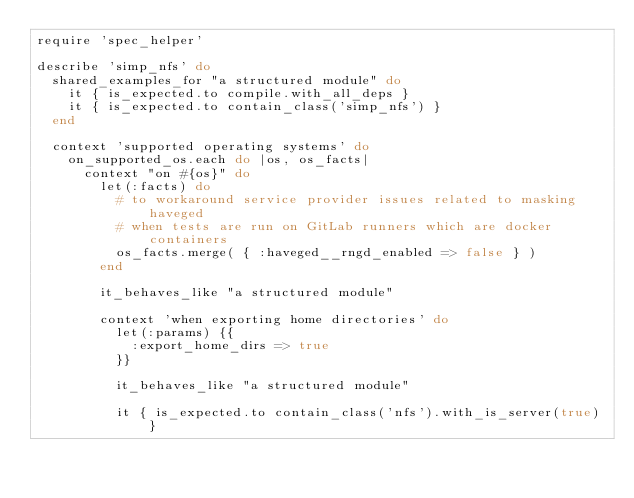Convert code to text. <code><loc_0><loc_0><loc_500><loc_500><_Ruby_>require 'spec_helper'

describe 'simp_nfs' do
  shared_examples_for "a structured module" do
    it { is_expected.to compile.with_all_deps }
    it { is_expected.to contain_class('simp_nfs') }
  end

  context 'supported operating systems' do
    on_supported_os.each do |os, os_facts|
      context "on #{os}" do
        let(:facts) do
          # to workaround service provider issues related to masking haveged
          # when tests are run on GitLab runners which are docker containers
          os_facts.merge( { :haveged__rngd_enabled => false } )
        end

        it_behaves_like "a structured module"

        context 'when exporting home directories' do
          let(:params) {{
            :export_home_dirs => true
          }}

          it_behaves_like "a structured module"

          it { is_expected.to contain_class('nfs').with_is_server(true) }</code> 